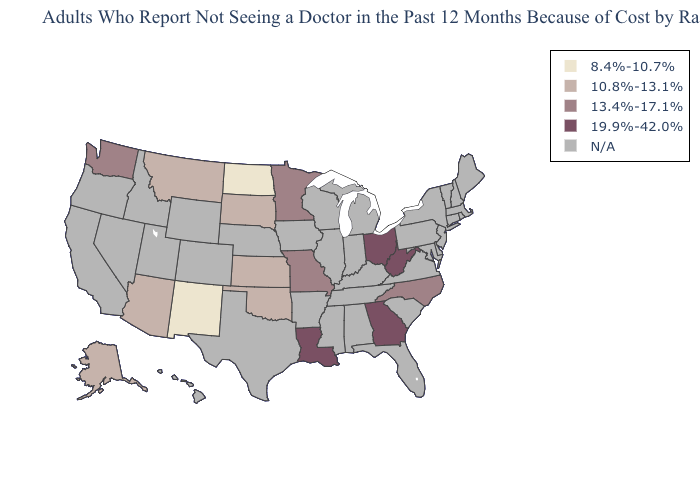Name the states that have a value in the range 13.4%-17.1%?
Give a very brief answer. Minnesota, Missouri, North Carolina, Washington. Does the map have missing data?
Short answer required. Yes. What is the highest value in states that border West Virginia?
Give a very brief answer. 19.9%-42.0%. How many symbols are there in the legend?
Write a very short answer. 5. What is the value of Nevada?
Short answer required. N/A. Name the states that have a value in the range 13.4%-17.1%?
Quick response, please. Minnesota, Missouri, North Carolina, Washington. Which states have the highest value in the USA?
Concise answer only. Georgia, Louisiana, Ohio, West Virginia. What is the value of Wyoming?
Give a very brief answer. N/A. What is the highest value in states that border North Carolina?
Give a very brief answer. 19.9%-42.0%. Name the states that have a value in the range 10.8%-13.1%?
Answer briefly. Alaska, Arizona, Kansas, Montana, Oklahoma, South Dakota. How many symbols are there in the legend?
Be succinct. 5. 